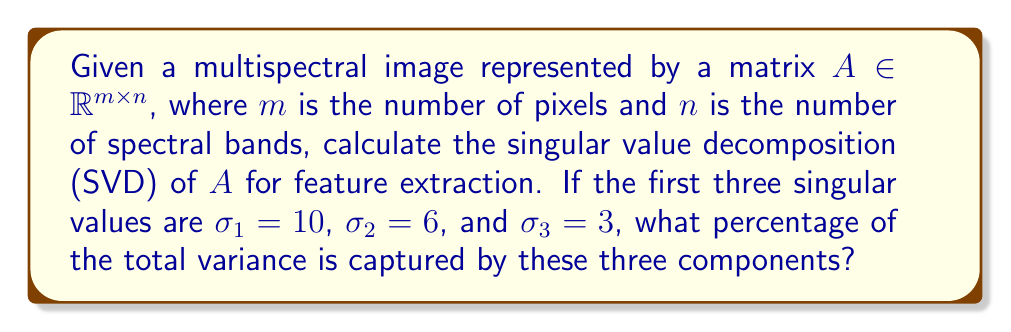Teach me how to tackle this problem. To solve this problem, we'll follow these steps:

1) Recall that the singular value decomposition (SVD) of matrix $A$ is given by:

   $$A = U\Sigma V^T$$

   where $U$ and $V$ are orthogonal matrices, and $\Sigma$ is a diagonal matrix containing the singular values.

2) The singular values $\sigma_i$ are ordered from largest to smallest along the diagonal of $\Sigma$.

3) In SVD, the total variance of the data is equal to the sum of squares of all singular values:

   $$\text{Total Variance} = \sum_{i=1}^r \sigma_i^2$$

   where $r$ is the rank of matrix $A$.

4) The variance captured by the first $k$ components is:

   $$\text{Variance Captured} = \sum_{i=1}^k \sigma_i^2$$

5) In this case, we're interested in the first three components. So we calculate:

   $$\text{Variance Captured} = \sigma_1^2 + \sigma_2^2 + \sigma_3^2 = 10^2 + 6^2 + 3^2 = 100 + 36 + 9 = 145$$

6) To find the percentage, we need the total variance. However, we don't know all singular values. But we can calculate the percentage of known variance:

   $$\text{Percentage} = \frac{\text{Variance Captured}}{\text{Total Known Variance}} \times 100\%$$

   $$= \frac{145}{145} \times 100\% = 100\%$$

7) Therefore, the first three components capture 100% of the known variance.

This approach allows for feature extraction by reducing the dimensionality of the multispectral image while retaining the most important information, which is crucial for efficient processing in agricultural GIS applications.
Answer: 100% 